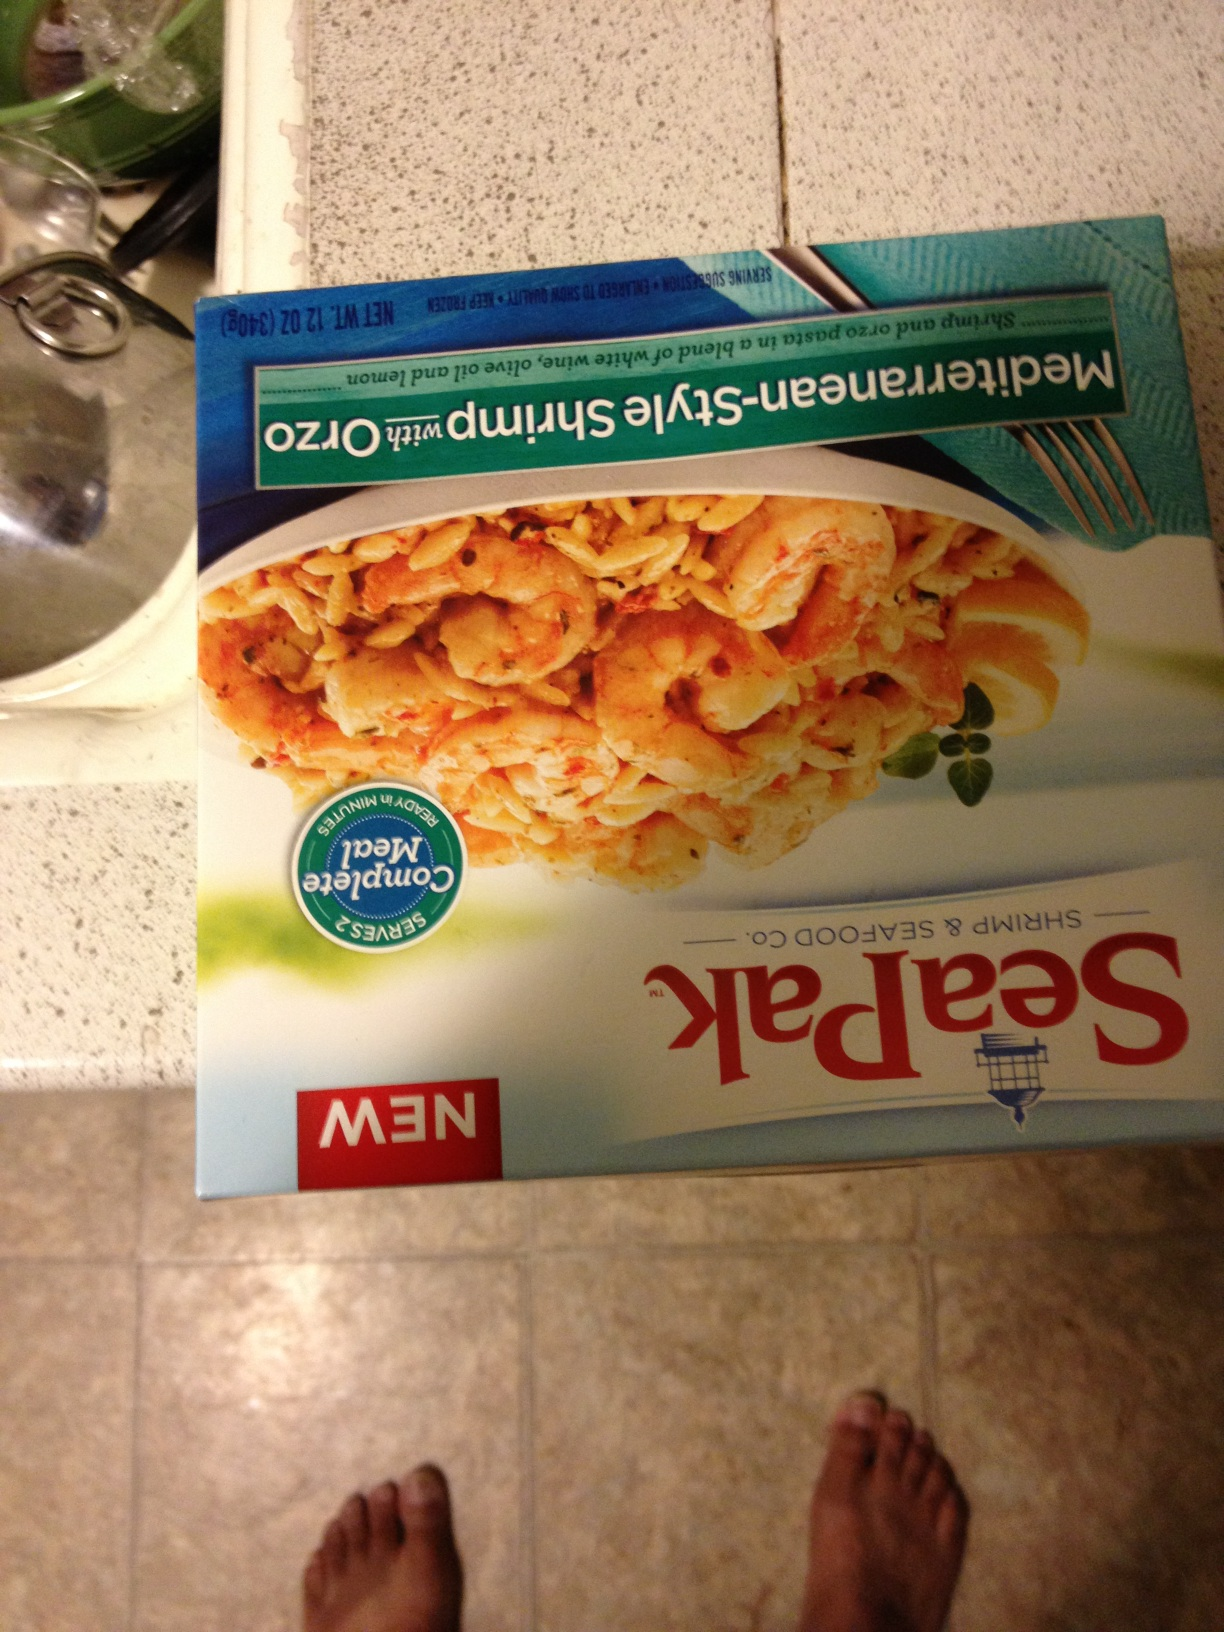Can you tell me if this product contains any allergens? The product is likely to contain shellfish, as it is a shrimp-based dish. Additionally, potential customers should check the packaging for other allergens like dairy, wheat, or soy, which are commonly used in prepared foods. Is this product easy to prepare? Yes, this shrimp scampi is designed for convenience and can typically be cooked quickly in a skillet or microwave, making it an easy meal option. 